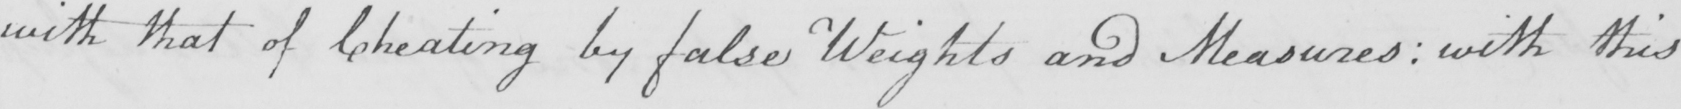Can you tell me what this handwritten text says? with that of Cheating by false Weights and Measures :  with this 